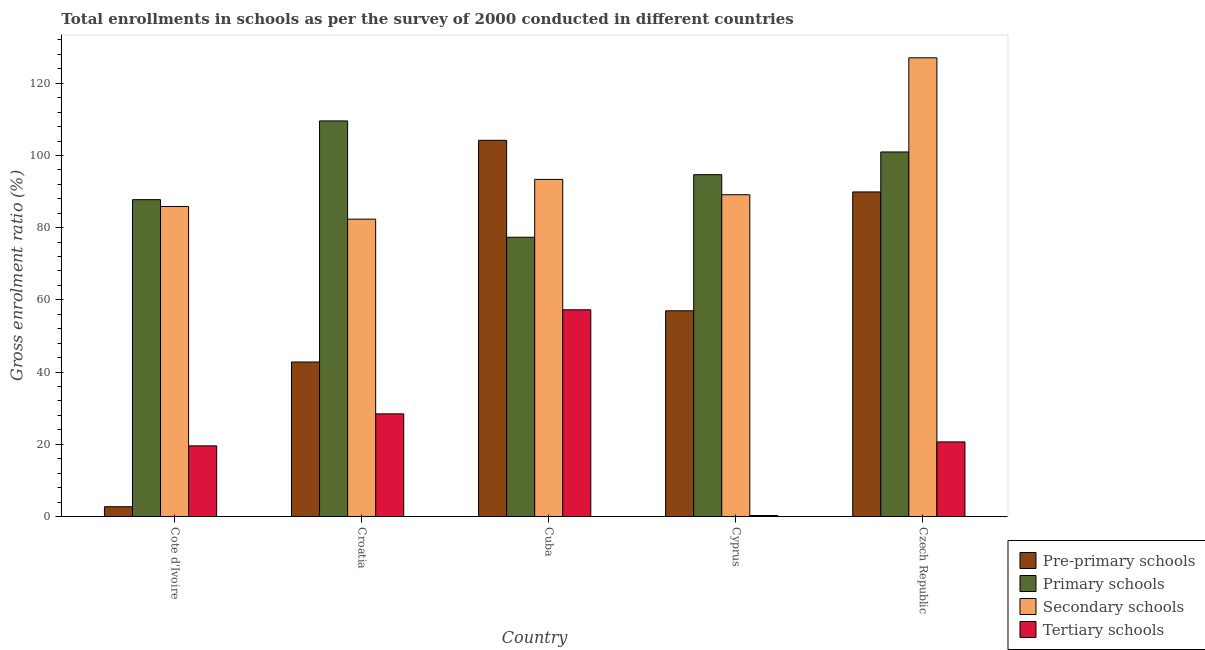How many different coloured bars are there?
Give a very brief answer. 4. Are the number of bars on each tick of the X-axis equal?
Offer a very short reply. Yes. What is the label of the 4th group of bars from the left?
Offer a very short reply. Cyprus. What is the gross enrolment ratio in pre-primary schools in Czech Republic?
Give a very brief answer. 89.9. Across all countries, what is the maximum gross enrolment ratio in pre-primary schools?
Keep it short and to the point. 104.2. Across all countries, what is the minimum gross enrolment ratio in pre-primary schools?
Offer a very short reply. 2.7. In which country was the gross enrolment ratio in primary schools maximum?
Your answer should be very brief. Croatia. In which country was the gross enrolment ratio in primary schools minimum?
Keep it short and to the point. Cuba. What is the total gross enrolment ratio in tertiary schools in the graph?
Provide a succinct answer. 126.17. What is the difference between the gross enrolment ratio in primary schools in Croatia and that in Cyprus?
Your answer should be compact. 14.89. What is the difference between the gross enrolment ratio in tertiary schools in Cyprus and the gross enrolment ratio in secondary schools in Czech Republic?
Offer a terse response. -126.79. What is the average gross enrolment ratio in primary schools per country?
Offer a terse response. 94.07. What is the difference between the gross enrolment ratio in primary schools and gross enrolment ratio in secondary schools in Cote d'Ivoire?
Provide a succinct answer. 1.9. In how many countries, is the gross enrolment ratio in primary schools greater than 28 %?
Provide a short and direct response. 5. What is the ratio of the gross enrolment ratio in tertiary schools in Cote d'Ivoire to that in Czech Republic?
Provide a short and direct response. 0.95. What is the difference between the highest and the second highest gross enrolment ratio in tertiary schools?
Make the answer very short. 28.82. What is the difference between the highest and the lowest gross enrolment ratio in secondary schools?
Make the answer very short. 44.69. What does the 4th bar from the left in Cyprus represents?
Keep it short and to the point. Tertiary schools. What does the 3rd bar from the right in Croatia represents?
Provide a short and direct response. Primary schools. Is it the case that in every country, the sum of the gross enrolment ratio in pre-primary schools and gross enrolment ratio in primary schools is greater than the gross enrolment ratio in secondary schools?
Ensure brevity in your answer.  Yes. How many bars are there?
Provide a short and direct response. 20. Are all the bars in the graph horizontal?
Make the answer very short. No. How many countries are there in the graph?
Offer a terse response. 5. Are the values on the major ticks of Y-axis written in scientific E-notation?
Provide a short and direct response. No. Does the graph contain any zero values?
Keep it short and to the point. No. Where does the legend appear in the graph?
Ensure brevity in your answer.  Bottom right. What is the title of the graph?
Your answer should be compact. Total enrollments in schools as per the survey of 2000 conducted in different countries. What is the Gross enrolment ratio (%) in Pre-primary schools in Cote d'Ivoire?
Make the answer very short. 2.7. What is the Gross enrolment ratio (%) in Primary schools in Cote d'Ivoire?
Offer a very short reply. 87.77. What is the Gross enrolment ratio (%) in Secondary schools in Cote d'Ivoire?
Offer a terse response. 85.87. What is the Gross enrolment ratio (%) in Tertiary schools in Cote d'Ivoire?
Keep it short and to the point. 19.56. What is the Gross enrolment ratio (%) in Pre-primary schools in Croatia?
Provide a short and direct response. 42.79. What is the Gross enrolment ratio (%) of Primary schools in Croatia?
Provide a short and direct response. 109.57. What is the Gross enrolment ratio (%) in Secondary schools in Croatia?
Offer a very short reply. 82.36. What is the Gross enrolment ratio (%) of Tertiary schools in Croatia?
Your response must be concise. 28.43. What is the Gross enrolment ratio (%) in Pre-primary schools in Cuba?
Provide a succinct answer. 104.2. What is the Gross enrolment ratio (%) of Primary schools in Cuba?
Ensure brevity in your answer.  77.35. What is the Gross enrolment ratio (%) in Secondary schools in Cuba?
Your answer should be very brief. 93.37. What is the Gross enrolment ratio (%) of Tertiary schools in Cuba?
Your answer should be very brief. 57.25. What is the Gross enrolment ratio (%) in Pre-primary schools in Cyprus?
Your answer should be very brief. 56.98. What is the Gross enrolment ratio (%) in Primary schools in Cyprus?
Provide a succinct answer. 94.68. What is the Gross enrolment ratio (%) in Secondary schools in Cyprus?
Offer a very short reply. 89.12. What is the Gross enrolment ratio (%) in Tertiary schools in Cyprus?
Make the answer very short. 0.27. What is the Gross enrolment ratio (%) of Pre-primary schools in Czech Republic?
Your response must be concise. 89.9. What is the Gross enrolment ratio (%) of Primary schools in Czech Republic?
Provide a short and direct response. 100.98. What is the Gross enrolment ratio (%) of Secondary schools in Czech Republic?
Your answer should be very brief. 127.05. What is the Gross enrolment ratio (%) of Tertiary schools in Czech Republic?
Ensure brevity in your answer.  20.66. Across all countries, what is the maximum Gross enrolment ratio (%) of Pre-primary schools?
Offer a terse response. 104.2. Across all countries, what is the maximum Gross enrolment ratio (%) in Primary schools?
Your answer should be compact. 109.57. Across all countries, what is the maximum Gross enrolment ratio (%) of Secondary schools?
Provide a succinct answer. 127.05. Across all countries, what is the maximum Gross enrolment ratio (%) in Tertiary schools?
Make the answer very short. 57.25. Across all countries, what is the minimum Gross enrolment ratio (%) of Pre-primary schools?
Keep it short and to the point. 2.7. Across all countries, what is the minimum Gross enrolment ratio (%) in Primary schools?
Offer a terse response. 77.35. Across all countries, what is the minimum Gross enrolment ratio (%) of Secondary schools?
Offer a very short reply. 82.36. Across all countries, what is the minimum Gross enrolment ratio (%) of Tertiary schools?
Ensure brevity in your answer.  0.27. What is the total Gross enrolment ratio (%) in Pre-primary schools in the graph?
Give a very brief answer. 296.57. What is the total Gross enrolment ratio (%) of Primary schools in the graph?
Ensure brevity in your answer.  470.34. What is the total Gross enrolment ratio (%) in Secondary schools in the graph?
Provide a short and direct response. 477.78. What is the total Gross enrolment ratio (%) of Tertiary schools in the graph?
Offer a terse response. 126.17. What is the difference between the Gross enrolment ratio (%) in Pre-primary schools in Cote d'Ivoire and that in Croatia?
Keep it short and to the point. -40.09. What is the difference between the Gross enrolment ratio (%) of Primary schools in Cote d'Ivoire and that in Croatia?
Make the answer very short. -21.81. What is the difference between the Gross enrolment ratio (%) in Secondary schools in Cote d'Ivoire and that in Croatia?
Your response must be concise. 3.5. What is the difference between the Gross enrolment ratio (%) of Tertiary schools in Cote d'Ivoire and that in Croatia?
Your answer should be very brief. -8.86. What is the difference between the Gross enrolment ratio (%) of Pre-primary schools in Cote d'Ivoire and that in Cuba?
Your answer should be compact. -101.5. What is the difference between the Gross enrolment ratio (%) of Primary schools in Cote d'Ivoire and that in Cuba?
Give a very brief answer. 10.42. What is the difference between the Gross enrolment ratio (%) of Secondary schools in Cote d'Ivoire and that in Cuba?
Offer a terse response. -7.51. What is the difference between the Gross enrolment ratio (%) of Tertiary schools in Cote d'Ivoire and that in Cuba?
Give a very brief answer. -37.69. What is the difference between the Gross enrolment ratio (%) in Pre-primary schools in Cote d'Ivoire and that in Cyprus?
Offer a terse response. -54.28. What is the difference between the Gross enrolment ratio (%) in Primary schools in Cote d'Ivoire and that in Cyprus?
Provide a succinct answer. -6.91. What is the difference between the Gross enrolment ratio (%) of Secondary schools in Cote d'Ivoire and that in Cyprus?
Your response must be concise. -3.26. What is the difference between the Gross enrolment ratio (%) of Tertiary schools in Cote d'Ivoire and that in Cyprus?
Keep it short and to the point. 19.3. What is the difference between the Gross enrolment ratio (%) in Pre-primary schools in Cote d'Ivoire and that in Czech Republic?
Your answer should be very brief. -87.2. What is the difference between the Gross enrolment ratio (%) of Primary schools in Cote d'Ivoire and that in Czech Republic?
Provide a succinct answer. -13.21. What is the difference between the Gross enrolment ratio (%) of Secondary schools in Cote d'Ivoire and that in Czech Republic?
Provide a short and direct response. -41.19. What is the difference between the Gross enrolment ratio (%) in Tertiary schools in Cote d'Ivoire and that in Czech Republic?
Ensure brevity in your answer.  -1.1. What is the difference between the Gross enrolment ratio (%) of Pre-primary schools in Croatia and that in Cuba?
Your answer should be compact. -61.41. What is the difference between the Gross enrolment ratio (%) in Primary schools in Croatia and that in Cuba?
Your response must be concise. 32.22. What is the difference between the Gross enrolment ratio (%) of Secondary schools in Croatia and that in Cuba?
Provide a succinct answer. -11.01. What is the difference between the Gross enrolment ratio (%) of Tertiary schools in Croatia and that in Cuba?
Offer a very short reply. -28.82. What is the difference between the Gross enrolment ratio (%) of Pre-primary schools in Croatia and that in Cyprus?
Provide a succinct answer. -14.19. What is the difference between the Gross enrolment ratio (%) of Primary schools in Croatia and that in Cyprus?
Give a very brief answer. 14.89. What is the difference between the Gross enrolment ratio (%) in Secondary schools in Croatia and that in Cyprus?
Provide a short and direct response. -6.76. What is the difference between the Gross enrolment ratio (%) of Tertiary schools in Croatia and that in Cyprus?
Make the answer very short. 28.16. What is the difference between the Gross enrolment ratio (%) in Pre-primary schools in Croatia and that in Czech Republic?
Provide a succinct answer. -47.11. What is the difference between the Gross enrolment ratio (%) of Primary schools in Croatia and that in Czech Republic?
Keep it short and to the point. 8.6. What is the difference between the Gross enrolment ratio (%) of Secondary schools in Croatia and that in Czech Republic?
Give a very brief answer. -44.69. What is the difference between the Gross enrolment ratio (%) of Tertiary schools in Croatia and that in Czech Republic?
Keep it short and to the point. 7.77. What is the difference between the Gross enrolment ratio (%) of Pre-primary schools in Cuba and that in Cyprus?
Ensure brevity in your answer.  47.22. What is the difference between the Gross enrolment ratio (%) of Primary schools in Cuba and that in Cyprus?
Your answer should be compact. -17.33. What is the difference between the Gross enrolment ratio (%) in Secondary schools in Cuba and that in Cyprus?
Make the answer very short. 4.25. What is the difference between the Gross enrolment ratio (%) of Tertiary schools in Cuba and that in Cyprus?
Offer a terse response. 56.98. What is the difference between the Gross enrolment ratio (%) of Pre-primary schools in Cuba and that in Czech Republic?
Keep it short and to the point. 14.3. What is the difference between the Gross enrolment ratio (%) of Primary schools in Cuba and that in Czech Republic?
Offer a very short reply. -23.63. What is the difference between the Gross enrolment ratio (%) of Secondary schools in Cuba and that in Czech Republic?
Give a very brief answer. -33.68. What is the difference between the Gross enrolment ratio (%) of Tertiary schools in Cuba and that in Czech Republic?
Provide a succinct answer. 36.59. What is the difference between the Gross enrolment ratio (%) of Pre-primary schools in Cyprus and that in Czech Republic?
Ensure brevity in your answer.  -32.92. What is the difference between the Gross enrolment ratio (%) in Primary schools in Cyprus and that in Czech Republic?
Give a very brief answer. -6.3. What is the difference between the Gross enrolment ratio (%) of Secondary schools in Cyprus and that in Czech Republic?
Give a very brief answer. -37.93. What is the difference between the Gross enrolment ratio (%) in Tertiary schools in Cyprus and that in Czech Republic?
Keep it short and to the point. -20.39. What is the difference between the Gross enrolment ratio (%) of Pre-primary schools in Cote d'Ivoire and the Gross enrolment ratio (%) of Primary schools in Croatia?
Provide a succinct answer. -106.87. What is the difference between the Gross enrolment ratio (%) of Pre-primary schools in Cote d'Ivoire and the Gross enrolment ratio (%) of Secondary schools in Croatia?
Give a very brief answer. -79.66. What is the difference between the Gross enrolment ratio (%) in Pre-primary schools in Cote d'Ivoire and the Gross enrolment ratio (%) in Tertiary schools in Croatia?
Provide a short and direct response. -25.73. What is the difference between the Gross enrolment ratio (%) of Primary schools in Cote d'Ivoire and the Gross enrolment ratio (%) of Secondary schools in Croatia?
Give a very brief answer. 5.4. What is the difference between the Gross enrolment ratio (%) in Primary schools in Cote d'Ivoire and the Gross enrolment ratio (%) in Tertiary schools in Croatia?
Offer a terse response. 59.34. What is the difference between the Gross enrolment ratio (%) of Secondary schools in Cote d'Ivoire and the Gross enrolment ratio (%) of Tertiary schools in Croatia?
Your answer should be very brief. 57.44. What is the difference between the Gross enrolment ratio (%) of Pre-primary schools in Cote d'Ivoire and the Gross enrolment ratio (%) of Primary schools in Cuba?
Your response must be concise. -74.65. What is the difference between the Gross enrolment ratio (%) in Pre-primary schools in Cote d'Ivoire and the Gross enrolment ratio (%) in Secondary schools in Cuba?
Your answer should be very brief. -90.67. What is the difference between the Gross enrolment ratio (%) of Pre-primary schools in Cote d'Ivoire and the Gross enrolment ratio (%) of Tertiary schools in Cuba?
Keep it short and to the point. -54.55. What is the difference between the Gross enrolment ratio (%) in Primary schools in Cote d'Ivoire and the Gross enrolment ratio (%) in Secondary schools in Cuba?
Offer a very short reply. -5.61. What is the difference between the Gross enrolment ratio (%) in Primary schools in Cote d'Ivoire and the Gross enrolment ratio (%) in Tertiary schools in Cuba?
Make the answer very short. 30.52. What is the difference between the Gross enrolment ratio (%) of Secondary schools in Cote d'Ivoire and the Gross enrolment ratio (%) of Tertiary schools in Cuba?
Offer a terse response. 28.62. What is the difference between the Gross enrolment ratio (%) in Pre-primary schools in Cote d'Ivoire and the Gross enrolment ratio (%) in Primary schools in Cyprus?
Offer a terse response. -91.98. What is the difference between the Gross enrolment ratio (%) of Pre-primary schools in Cote d'Ivoire and the Gross enrolment ratio (%) of Secondary schools in Cyprus?
Provide a succinct answer. -86.42. What is the difference between the Gross enrolment ratio (%) in Pre-primary schools in Cote d'Ivoire and the Gross enrolment ratio (%) in Tertiary schools in Cyprus?
Your response must be concise. 2.43. What is the difference between the Gross enrolment ratio (%) of Primary schools in Cote d'Ivoire and the Gross enrolment ratio (%) of Secondary schools in Cyprus?
Your response must be concise. -1.36. What is the difference between the Gross enrolment ratio (%) of Primary schools in Cote d'Ivoire and the Gross enrolment ratio (%) of Tertiary schools in Cyprus?
Your answer should be compact. 87.5. What is the difference between the Gross enrolment ratio (%) in Secondary schools in Cote d'Ivoire and the Gross enrolment ratio (%) in Tertiary schools in Cyprus?
Provide a succinct answer. 85.6. What is the difference between the Gross enrolment ratio (%) in Pre-primary schools in Cote d'Ivoire and the Gross enrolment ratio (%) in Primary schools in Czech Republic?
Provide a short and direct response. -98.27. What is the difference between the Gross enrolment ratio (%) of Pre-primary schools in Cote d'Ivoire and the Gross enrolment ratio (%) of Secondary schools in Czech Republic?
Your response must be concise. -124.35. What is the difference between the Gross enrolment ratio (%) of Pre-primary schools in Cote d'Ivoire and the Gross enrolment ratio (%) of Tertiary schools in Czech Republic?
Offer a terse response. -17.96. What is the difference between the Gross enrolment ratio (%) in Primary schools in Cote d'Ivoire and the Gross enrolment ratio (%) in Secondary schools in Czech Republic?
Offer a very short reply. -39.29. What is the difference between the Gross enrolment ratio (%) of Primary schools in Cote d'Ivoire and the Gross enrolment ratio (%) of Tertiary schools in Czech Republic?
Keep it short and to the point. 67.11. What is the difference between the Gross enrolment ratio (%) of Secondary schools in Cote d'Ivoire and the Gross enrolment ratio (%) of Tertiary schools in Czech Republic?
Provide a short and direct response. 65.21. What is the difference between the Gross enrolment ratio (%) of Pre-primary schools in Croatia and the Gross enrolment ratio (%) of Primary schools in Cuba?
Provide a succinct answer. -34.56. What is the difference between the Gross enrolment ratio (%) in Pre-primary schools in Croatia and the Gross enrolment ratio (%) in Secondary schools in Cuba?
Your response must be concise. -50.58. What is the difference between the Gross enrolment ratio (%) of Pre-primary schools in Croatia and the Gross enrolment ratio (%) of Tertiary schools in Cuba?
Offer a terse response. -14.46. What is the difference between the Gross enrolment ratio (%) of Primary schools in Croatia and the Gross enrolment ratio (%) of Secondary schools in Cuba?
Make the answer very short. 16.2. What is the difference between the Gross enrolment ratio (%) of Primary schools in Croatia and the Gross enrolment ratio (%) of Tertiary schools in Cuba?
Ensure brevity in your answer.  52.32. What is the difference between the Gross enrolment ratio (%) of Secondary schools in Croatia and the Gross enrolment ratio (%) of Tertiary schools in Cuba?
Provide a short and direct response. 25.11. What is the difference between the Gross enrolment ratio (%) of Pre-primary schools in Croatia and the Gross enrolment ratio (%) of Primary schools in Cyprus?
Offer a very short reply. -51.89. What is the difference between the Gross enrolment ratio (%) in Pre-primary schools in Croatia and the Gross enrolment ratio (%) in Secondary schools in Cyprus?
Provide a succinct answer. -46.33. What is the difference between the Gross enrolment ratio (%) of Pre-primary schools in Croatia and the Gross enrolment ratio (%) of Tertiary schools in Cyprus?
Your response must be concise. 42.52. What is the difference between the Gross enrolment ratio (%) in Primary schools in Croatia and the Gross enrolment ratio (%) in Secondary schools in Cyprus?
Provide a short and direct response. 20.45. What is the difference between the Gross enrolment ratio (%) of Primary schools in Croatia and the Gross enrolment ratio (%) of Tertiary schools in Cyprus?
Give a very brief answer. 109.31. What is the difference between the Gross enrolment ratio (%) in Secondary schools in Croatia and the Gross enrolment ratio (%) in Tertiary schools in Cyprus?
Offer a terse response. 82.1. What is the difference between the Gross enrolment ratio (%) of Pre-primary schools in Croatia and the Gross enrolment ratio (%) of Primary schools in Czech Republic?
Offer a terse response. -58.19. What is the difference between the Gross enrolment ratio (%) in Pre-primary schools in Croatia and the Gross enrolment ratio (%) in Secondary schools in Czech Republic?
Offer a very short reply. -84.26. What is the difference between the Gross enrolment ratio (%) of Pre-primary schools in Croatia and the Gross enrolment ratio (%) of Tertiary schools in Czech Republic?
Provide a short and direct response. 22.13. What is the difference between the Gross enrolment ratio (%) in Primary schools in Croatia and the Gross enrolment ratio (%) in Secondary schools in Czech Republic?
Ensure brevity in your answer.  -17.48. What is the difference between the Gross enrolment ratio (%) in Primary schools in Croatia and the Gross enrolment ratio (%) in Tertiary schools in Czech Republic?
Keep it short and to the point. 88.91. What is the difference between the Gross enrolment ratio (%) of Secondary schools in Croatia and the Gross enrolment ratio (%) of Tertiary schools in Czech Republic?
Your answer should be very brief. 61.7. What is the difference between the Gross enrolment ratio (%) of Pre-primary schools in Cuba and the Gross enrolment ratio (%) of Primary schools in Cyprus?
Provide a short and direct response. 9.52. What is the difference between the Gross enrolment ratio (%) of Pre-primary schools in Cuba and the Gross enrolment ratio (%) of Secondary schools in Cyprus?
Your answer should be compact. 15.08. What is the difference between the Gross enrolment ratio (%) of Pre-primary schools in Cuba and the Gross enrolment ratio (%) of Tertiary schools in Cyprus?
Give a very brief answer. 103.93. What is the difference between the Gross enrolment ratio (%) in Primary schools in Cuba and the Gross enrolment ratio (%) in Secondary schools in Cyprus?
Offer a terse response. -11.78. What is the difference between the Gross enrolment ratio (%) of Primary schools in Cuba and the Gross enrolment ratio (%) of Tertiary schools in Cyprus?
Offer a terse response. 77.08. What is the difference between the Gross enrolment ratio (%) of Secondary schools in Cuba and the Gross enrolment ratio (%) of Tertiary schools in Cyprus?
Make the answer very short. 93.11. What is the difference between the Gross enrolment ratio (%) of Pre-primary schools in Cuba and the Gross enrolment ratio (%) of Primary schools in Czech Republic?
Your answer should be compact. 3.23. What is the difference between the Gross enrolment ratio (%) of Pre-primary schools in Cuba and the Gross enrolment ratio (%) of Secondary schools in Czech Republic?
Give a very brief answer. -22.85. What is the difference between the Gross enrolment ratio (%) in Pre-primary schools in Cuba and the Gross enrolment ratio (%) in Tertiary schools in Czech Republic?
Offer a very short reply. 83.54. What is the difference between the Gross enrolment ratio (%) of Primary schools in Cuba and the Gross enrolment ratio (%) of Secondary schools in Czech Republic?
Your answer should be very brief. -49.71. What is the difference between the Gross enrolment ratio (%) in Primary schools in Cuba and the Gross enrolment ratio (%) in Tertiary schools in Czech Republic?
Keep it short and to the point. 56.69. What is the difference between the Gross enrolment ratio (%) in Secondary schools in Cuba and the Gross enrolment ratio (%) in Tertiary schools in Czech Republic?
Your answer should be very brief. 72.71. What is the difference between the Gross enrolment ratio (%) in Pre-primary schools in Cyprus and the Gross enrolment ratio (%) in Primary schools in Czech Republic?
Ensure brevity in your answer.  -44. What is the difference between the Gross enrolment ratio (%) of Pre-primary schools in Cyprus and the Gross enrolment ratio (%) of Secondary schools in Czech Republic?
Keep it short and to the point. -70.08. What is the difference between the Gross enrolment ratio (%) in Pre-primary schools in Cyprus and the Gross enrolment ratio (%) in Tertiary schools in Czech Republic?
Provide a short and direct response. 36.32. What is the difference between the Gross enrolment ratio (%) in Primary schools in Cyprus and the Gross enrolment ratio (%) in Secondary schools in Czech Republic?
Offer a terse response. -32.38. What is the difference between the Gross enrolment ratio (%) in Primary schools in Cyprus and the Gross enrolment ratio (%) in Tertiary schools in Czech Republic?
Give a very brief answer. 74.02. What is the difference between the Gross enrolment ratio (%) of Secondary schools in Cyprus and the Gross enrolment ratio (%) of Tertiary schools in Czech Republic?
Offer a very short reply. 68.46. What is the average Gross enrolment ratio (%) in Pre-primary schools per country?
Make the answer very short. 59.31. What is the average Gross enrolment ratio (%) in Primary schools per country?
Provide a succinct answer. 94.07. What is the average Gross enrolment ratio (%) in Secondary schools per country?
Provide a succinct answer. 95.56. What is the average Gross enrolment ratio (%) of Tertiary schools per country?
Provide a succinct answer. 25.23. What is the difference between the Gross enrolment ratio (%) of Pre-primary schools and Gross enrolment ratio (%) of Primary schools in Cote d'Ivoire?
Offer a very short reply. -85.06. What is the difference between the Gross enrolment ratio (%) of Pre-primary schools and Gross enrolment ratio (%) of Secondary schools in Cote d'Ivoire?
Keep it short and to the point. -83.17. What is the difference between the Gross enrolment ratio (%) of Pre-primary schools and Gross enrolment ratio (%) of Tertiary schools in Cote d'Ivoire?
Provide a succinct answer. -16.86. What is the difference between the Gross enrolment ratio (%) of Primary schools and Gross enrolment ratio (%) of Secondary schools in Cote d'Ivoire?
Provide a short and direct response. 1.9. What is the difference between the Gross enrolment ratio (%) of Primary schools and Gross enrolment ratio (%) of Tertiary schools in Cote d'Ivoire?
Provide a short and direct response. 68.2. What is the difference between the Gross enrolment ratio (%) in Secondary schools and Gross enrolment ratio (%) in Tertiary schools in Cote d'Ivoire?
Make the answer very short. 66.3. What is the difference between the Gross enrolment ratio (%) in Pre-primary schools and Gross enrolment ratio (%) in Primary schools in Croatia?
Make the answer very short. -66.78. What is the difference between the Gross enrolment ratio (%) in Pre-primary schools and Gross enrolment ratio (%) in Secondary schools in Croatia?
Give a very brief answer. -39.57. What is the difference between the Gross enrolment ratio (%) of Pre-primary schools and Gross enrolment ratio (%) of Tertiary schools in Croatia?
Your response must be concise. 14.36. What is the difference between the Gross enrolment ratio (%) of Primary schools and Gross enrolment ratio (%) of Secondary schools in Croatia?
Keep it short and to the point. 27.21. What is the difference between the Gross enrolment ratio (%) in Primary schools and Gross enrolment ratio (%) in Tertiary schools in Croatia?
Give a very brief answer. 81.15. What is the difference between the Gross enrolment ratio (%) of Secondary schools and Gross enrolment ratio (%) of Tertiary schools in Croatia?
Offer a very short reply. 53.94. What is the difference between the Gross enrolment ratio (%) in Pre-primary schools and Gross enrolment ratio (%) in Primary schools in Cuba?
Your answer should be compact. 26.85. What is the difference between the Gross enrolment ratio (%) of Pre-primary schools and Gross enrolment ratio (%) of Secondary schools in Cuba?
Your response must be concise. 10.83. What is the difference between the Gross enrolment ratio (%) of Pre-primary schools and Gross enrolment ratio (%) of Tertiary schools in Cuba?
Your answer should be very brief. 46.95. What is the difference between the Gross enrolment ratio (%) in Primary schools and Gross enrolment ratio (%) in Secondary schools in Cuba?
Offer a terse response. -16.02. What is the difference between the Gross enrolment ratio (%) of Primary schools and Gross enrolment ratio (%) of Tertiary schools in Cuba?
Your answer should be compact. 20.1. What is the difference between the Gross enrolment ratio (%) of Secondary schools and Gross enrolment ratio (%) of Tertiary schools in Cuba?
Your response must be concise. 36.12. What is the difference between the Gross enrolment ratio (%) of Pre-primary schools and Gross enrolment ratio (%) of Primary schools in Cyprus?
Your answer should be very brief. -37.7. What is the difference between the Gross enrolment ratio (%) of Pre-primary schools and Gross enrolment ratio (%) of Secondary schools in Cyprus?
Make the answer very short. -32.15. What is the difference between the Gross enrolment ratio (%) in Pre-primary schools and Gross enrolment ratio (%) in Tertiary schools in Cyprus?
Make the answer very short. 56.71. What is the difference between the Gross enrolment ratio (%) in Primary schools and Gross enrolment ratio (%) in Secondary schools in Cyprus?
Offer a very short reply. 5.56. What is the difference between the Gross enrolment ratio (%) of Primary schools and Gross enrolment ratio (%) of Tertiary schools in Cyprus?
Your answer should be very brief. 94.41. What is the difference between the Gross enrolment ratio (%) in Secondary schools and Gross enrolment ratio (%) in Tertiary schools in Cyprus?
Ensure brevity in your answer.  88.86. What is the difference between the Gross enrolment ratio (%) of Pre-primary schools and Gross enrolment ratio (%) of Primary schools in Czech Republic?
Offer a very short reply. -11.08. What is the difference between the Gross enrolment ratio (%) of Pre-primary schools and Gross enrolment ratio (%) of Secondary schools in Czech Republic?
Offer a very short reply. -37.16. What is the difference between the Gross enrolment ratio (%) of Pre-primary schools and Gross enrolment ratio (%) of Tertiary schools in Czech Republic?
Offer a terse response. 69.24. What is the difference between the Gross enrolment ratio (%) of Primary schools and Gross enrolment ratio (%) of Secondary schools in Czech Republic?
Your answer should be compact. -26.08. What is the difference between the Gross enrolment ratio (%) of Primary schools and Gross enrolment ratio (%) of Tertiary schools in Czech Republic?
Offer a very short reply. 80.32. What is the difference between the Gross enrolment ratio (%) in Secondary schools and Gross enrolment ratio (%) in Tertiary schools in Czech Republic?
Offer a very short reply. 106.39. What is the ratio of the Gross enrolment ratio (%) of Pre-primary schools in Cote d'Ivoire to that in Croatia?
Your response must be concise. 0.06. What is the ratio of the Gross enrolment ratio (%) in Primary schools in Cote d'Ivoire to that in Croatia?
Give a very brief answer. 0.8. What is the ratio of the Gross enrolment ratio (%) in Secondary schools in Cote d'Ivoire to that in Croatia?
Your answer should be very brief. 1.04. What is the ratio of the Gross enrolment ratio (%) in Tertiary schools in Cote d'Ivoire to that in Croatia?
Your answer should be compact. 0.69. What is the ratio of the Gross enrolment ratio (%) of Pre-primary schools in Cote d'Ivoire to that in Cuba?
Make the answer very short. 0.03. What is the ratio of the Gross enrolment ratio (%) in Primary schools in Cote d'Ivoire to that in Cuba?
Your answer should be very brief. 1.13. What is the ratio of the Gross enrolment ratio (%) of Secondary schools in Cote d'Ivoire to that in Cuba?
Ensure brevity in your answer.  0.92. What is the ratio of the Gross enrolment ratio (%) of Tertiary schools in Cote d'Ivoire to that in Cuba?
Keep it short and to the point. 0.34. What is the ratio of the Gross enrolment ratio (%) in Pre-primary schools in Cote d'Ivoire to that in Cyprus?
Give a very brief answer. 0.05. What is the ratio of the Gross enrolment ratio (%) in Primary schools in Cote d'Ivoire to that in Cyprus?
Give a very brief answer. 0.93. What is the ratio of the Gross enrolment ratio (%) in Secondary schools in Cote d'Ivoire to that in Cyprus?
Your answer should be very brief. 0.96. What is the ratio of the Gross enrolment ratio (%) in Tertiary schools in Cote d'Ivoire to that in Cyprus?
Make the answer very short. 73.22. What is the ratio of the Gross enrolment ratio (%) of Primary schools in Cote d'Ivoire to that in Czech Republic?
Make the answer very short. 0.87. What is the ratio of the Gross enrolment ratio (%) in Secondary schools in Cote d'Ivoire to that in Czech Republic?
Keep it short and to the point. 0.68. What is the ratio of the Gross enrolment ratio (%) in Tertiary schools in Cote d'Ivoire to that in Czech Republic?
Offer a terse response. 0.95. What is the ratio of the Gross enrolment ratio (%) of Pre-primary schools in Croatia to that in Cuba?
Provide a short and direct response. 0.41. What is the ratio of the Gross enrolment ratio (%) of Primary schools in Croatia to that in Cuba?
Make the answer very short. 1.42. What is the ratio of the Gross enrolment ratio (%) in Secondary schools in Croatia to that in Cuba?
Your answer should be very brief. 0.88. What is the ratio of the Gross enrolment ratio (%) in Tertiary schools in Croatia to that in Cuba?
Offer a very short reply. 0.5. What is the ratio of the Gross enrolment ratio (%) of Pre-primary schools in Croatia to that in Cyprus?
Your response must be concise. 0.75. What is the ratio of the Gross enrolment ratio (%) in Primary schools in Croatia to that in Cyprus?
Provide a short and direct response. 1.16. What is the ratio of the Gross enrolment ratio (%) of Secondary schools in Croatia to that in Cyprus?
Make the answer very short. 0.92. What is the ratio of the Gross enrolment ratio (%) in Tertiary schools in Croatia to that in Cyprus?
Provide a succinct answer. 106.4. What is the ratio of the Gross enrolment ratio (%) of Pre-primary schools in Croatia to that in Czech Republic?
Provide a succinct answer. 0.48. What is the ratio of the Gross enrolment ratio (%) of Primary schools in Croatia to that in Czech Republic?
Make the answer very short. 1.09. What is the ratio of the Gross enrolment ratio (%) in Secondary schools in Croatia to that in Czech Republic?
Your answer should be compact. 0.65. What is the ratio of the Gross enrolment ratio (%) in Tertiary schools in Croatia to that in Czech Republic?
Offer a terse response. 1.38. What is the ratio of the Gross enrolment ratio (%) of Pre-primary schools in Cuba to that in Cyprus?
Provide a short and direct response. 1.83. What is the ratio of the Gross enrolment ratio (%) in Primary schools in Cuba to that in Cyprus?
Keep it short and to the point. 0.82. What is the ratio of the Gross enrolment ratio (%) of Secondary schools in Cuba to that in Cyprus?
Offer a very short reply. 1.05. What is the ratio of the Gross enrolment ratio (%) of Tertiary schools in Cuba to that in Cyprus?
Provide a short and direct response. 214.27. What is the ratio of the Gross enrolment ratio (%) in Pre-primary schools in Cuba to that in Czech Republic?
Offer a very short reply. 1.16. What is the ratio of the Gross enrolment ratio (%) in Primary schools in Cuba to that in Czech Republic?
Ensure brevity in your answer.  0.77. What is the ratio of the Gross enrolment ratio (%) of Secondary schools in Cuba to that in Czech Republic?
Ensure brevity in your answer.  0.73. What is the ratio of the Gross enrolment ratio (%) in Tertiary schools in Cuba to that in Czech Republic?
Your response must be concise. 2.77. What is the ratio of the Gross enrolment ratio (%) in Pre-primary schools in Cyprus to that in Czech Republic?
Ensure brevity in your answer.  0.63. What is the ratio of the Gross enrolment ratio (%) in Primary schools in Cyprus to that in Czech Republic?
Offer a terse response. 0.94. What is the ratio of the Gross enrolment ratio (%) in Secondary schools in Cyprus to that in Czech Republic?
Make the answer very short. 0.7. What is the ratio of the Gross enrolment ratio (%) of Tertiary schools in Cyprus to that in Czech Republic?
Keep it short and to the point. 0.01. What is the difference between the highest and the second highest Gross enrolment ratio (%) in Pre-primary schools?
Make the answer very short. 14.3. What is the difference between the highest and the second highest Gross enrolment ratio (%) of Primary schools?
Keep it short and to the point. 8.6. What is the difference between the highest and the second highest Gross enrolment ratio (%) in Secondary schools?
Offer a very short reply. 33.68. What is the difference between the highest and the second highest Gross enrolment ratio (%) of Tertiary schools?
Give a very brief answer. 28.82. What is the difference between the highest and the lowest Gross enrolment ratio (%) in Pre-primary schools?
Offer a terse response. 101.5. What is the difference between the highest and the lowest Gross enrolment ratio (%) of Primary schools?
Ensure brevity in your answer.  32.22. What is the difference between the highest and the lowest Gross enrolment ratio (%) of Secondary schools?
Your response must be concise. 44.69. What is the difference between the highest and the lowest Gross enrolment ratio (%) in Tertiary schools?
Your response must be concise. 56.98. 